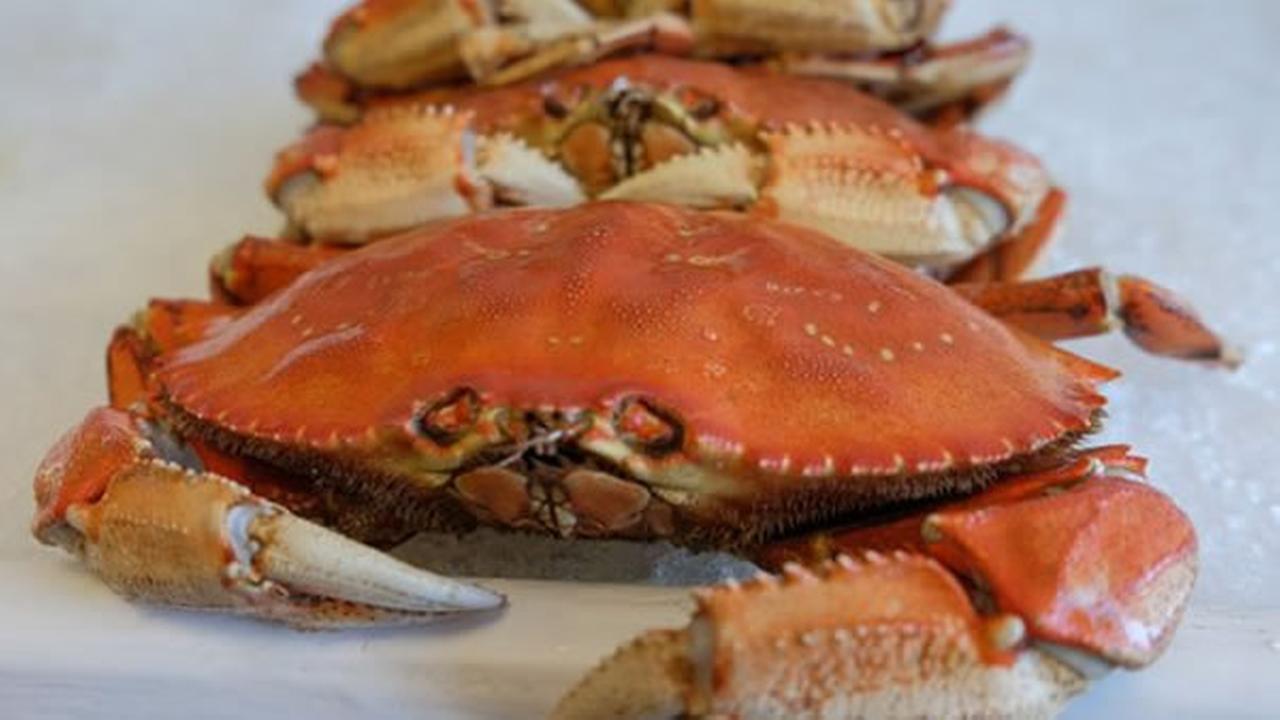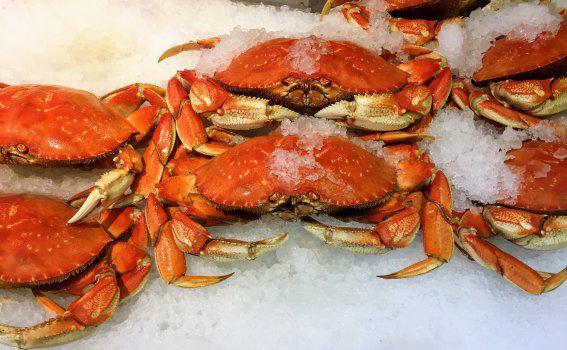The first image is the image on the left, the second image is the image on the right. Examine the images to the left and right. Is the description "There is only one crab in at least one of the images." accurate? Answer yes or no. No. The first image is the image on the left, the second image is the image on the right. For the images displayed, is the sentence "All images include at least one forward-facing reddish-orange crab with its shell intact." factually correct? Answer yes or no. Yes. 